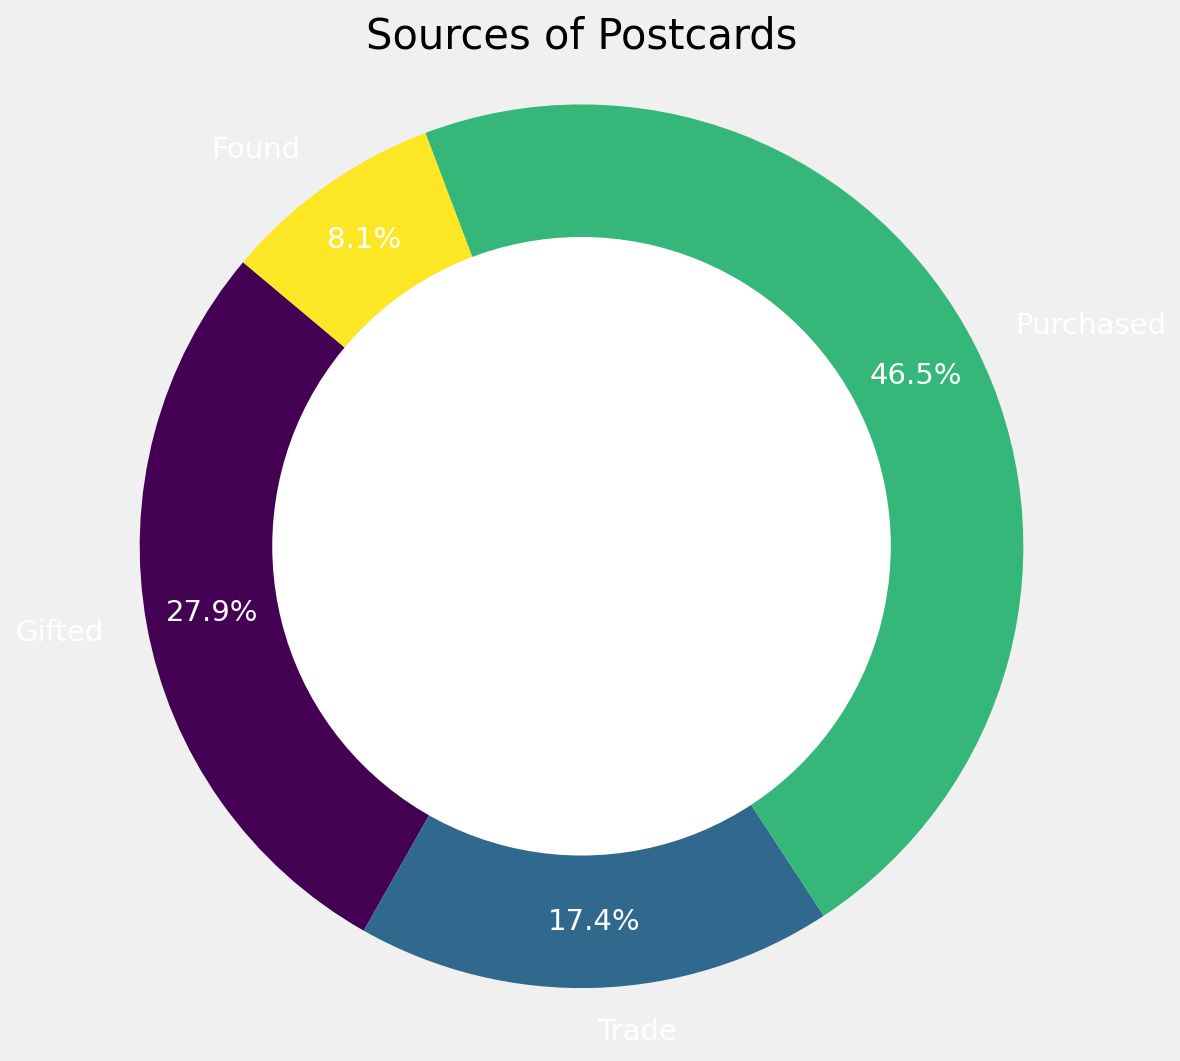Which source has the largest share of postcards? By looking at the pie chart, the largest section represents the greatest share. The "Purchased" segment is clearly the largest.
Answer: Purchased What percentage of postcards were gifted? The pie chart labels show percentages for each category. The "Gifted" section is labeled with its percentage, which is 26.4%.
Answer: 26.4% Is the combined percentage of "Found" and "Trade" more or less than "Purchased"? Adding the percentages for "Found" (7.7%) and "Trade" (16.5%) gives 24.2%, which is less than the 44.0% for "Purchased".
Answer: Less What is the total percentage represented by "Trade" and "Gifted"? The pie chart shows "Trade" is 16.5% and "Gifted" is 26.4%. Adding these gives 42.9%.
Answer: 42.9% Which two sources have the smallest totals? By examining the pie chart, the smallest sections are "Found" and "Trade".
Answer: Found and Trade By how much does the "Purchased" segment exceed the "Gifted" segment in percentage points? The pie chart shows "Purchased" at 44.0% and "Gifted" at 26.4%. Subtracting 26.4 from 44.0 gives 17.6 percentage points.
Answer: 17.6 Do "Gifted", "Trade", and "Found" together account for more than half the total postcards? Summing the percentages for "Gifted" (26.4%), "Trade" (16.5%), and "Found" (7.7%) gives 50.6%. As this is more than 50%, the answer is yes.
Answer: Yes Which segment is represented by a greenish color on the pie chart? Observing the colors, the segment shown in greenish is "Trade".
Answer: Trade 